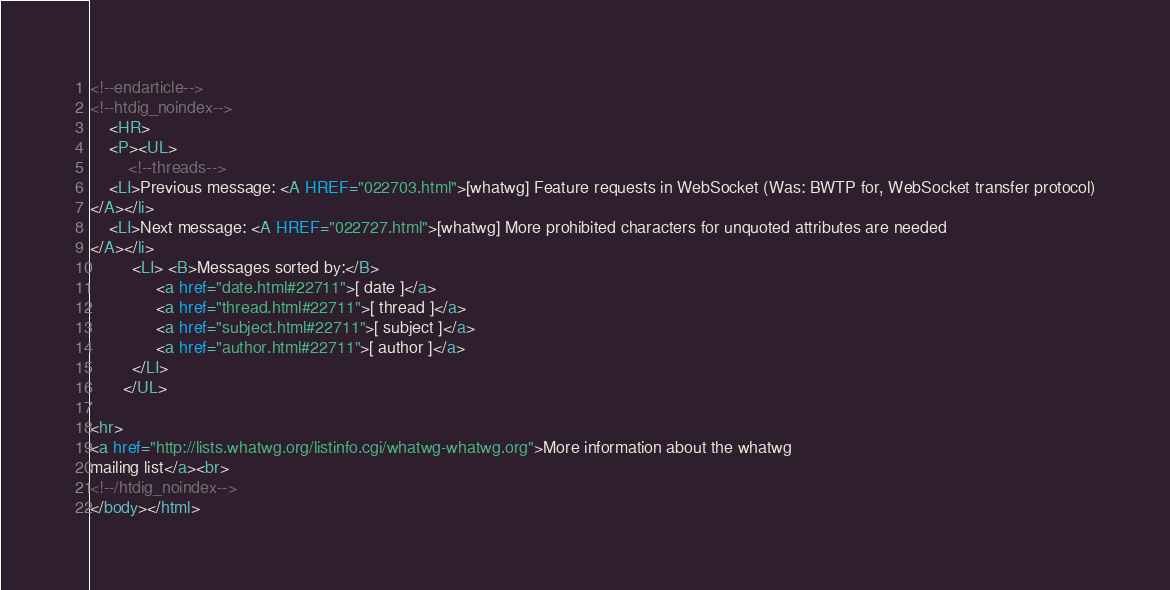<code> <loc_0><loc_0><loc_500><loc_500><_HTML_>









































































































<!--endarticle-->
<!--htdig_noindex-->
    <HR>
    <P><UL>
        <!--threads-->
	<LI>Previous message: <A HREF="022703.html">[whatwg] Feature requests in WebSocket (Was: BWTP for, WebSocket transfer protocol)
</A></li>
	<LI>Next message: <A HREF="022727.html">[whatwg] More prohibited characters for unquoted attributes are	needed
</A></li>
         <LI> <B>Messages sorted by:</B> 
              <a href="date.html#22711">[ date ]</a>
              <a href="thread.html#22711">[ thread ]</a>
              <a href="subject.html#22711">[ subject ]</a>
              <a href="author.html#22711">[ author ]</a>
         </LI>
       </UL>

<hr>
<a href="http://lists.whatwg.org/listinfo.cgi/whatwg-whatwg.org">More information about the whatwg
mailing list</a><br>
<!--/htdig_noindex-->
</body></html>
</code> 